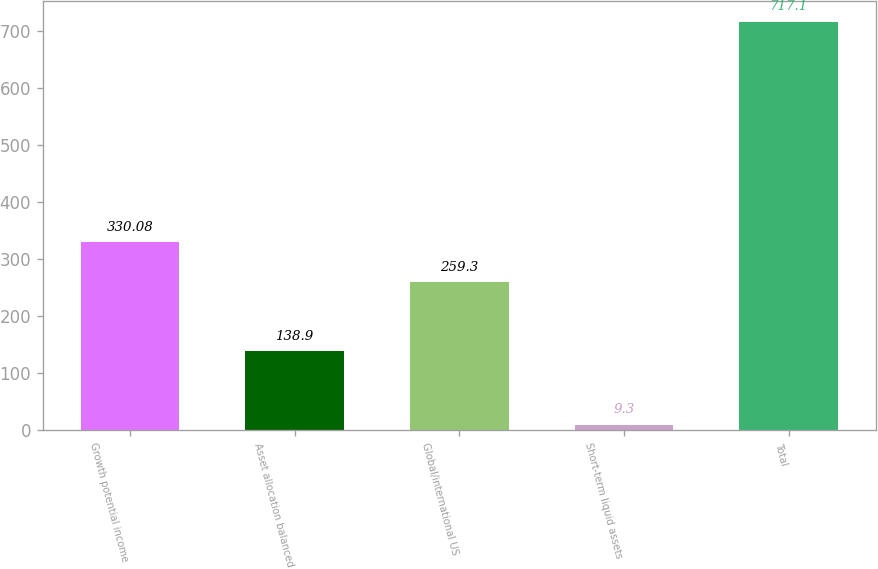<chart> <loc_0><loc_0><loc_500><loc_500><bar_chart><fcel>Growth potential income<fcel>Asset allocation balanced<fcel>Global/international US<fcel>Short-term liquid assets<fcel>Total<nl><fcel>330.08<fcel>138.9<fcel>259.3<fcel>9.3<fcel>717.1<nl></chart> 